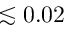<formula> <loc_0><loc_0><loc_500><loc_500>\lesssim 0 . 0 2</formula> 